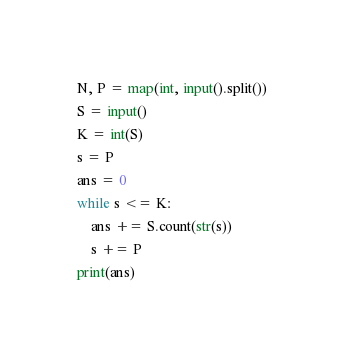Convert code to text. <code><loc_0><loc_0><loc_500><loc_500><_Python_>N, P = map(int, input().split())
S = input()
K = int(S)
s = P
ans = 0
while s <= K:
    ans += S.count(str(s))
    s += P
print(ans)</code> 